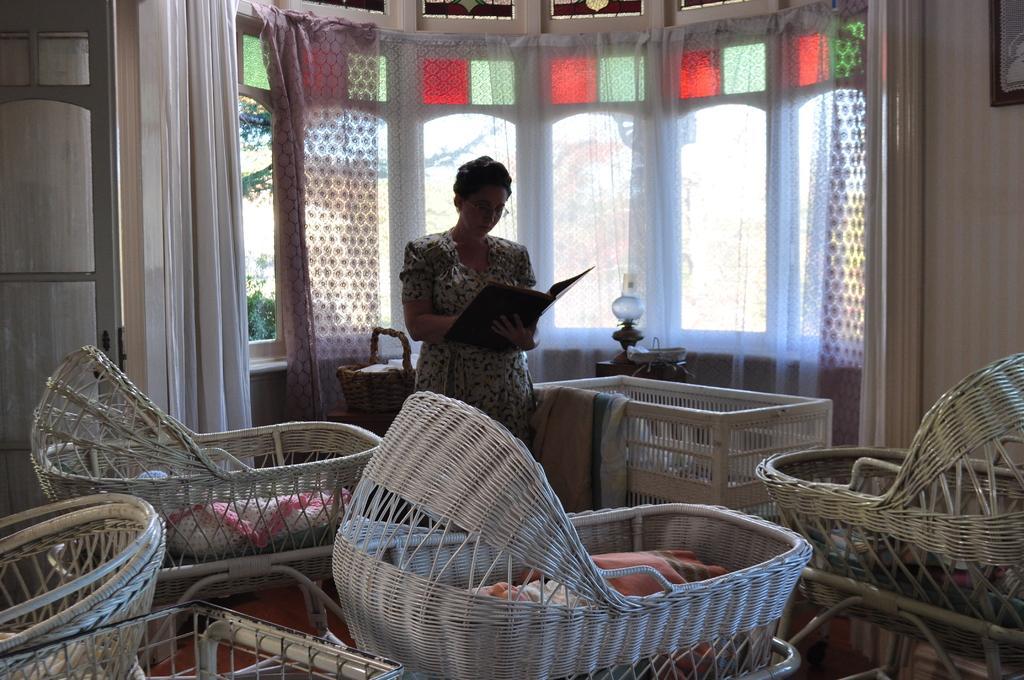How would you summarize this image in a sentence or two? In this image, we can see some bassinets. There is a door on the left side of the image. There is a person in the middle of the image wearing clothes and holding a file with her hand. There is a window at the top of the image. There is a wall on the right side of the image. 